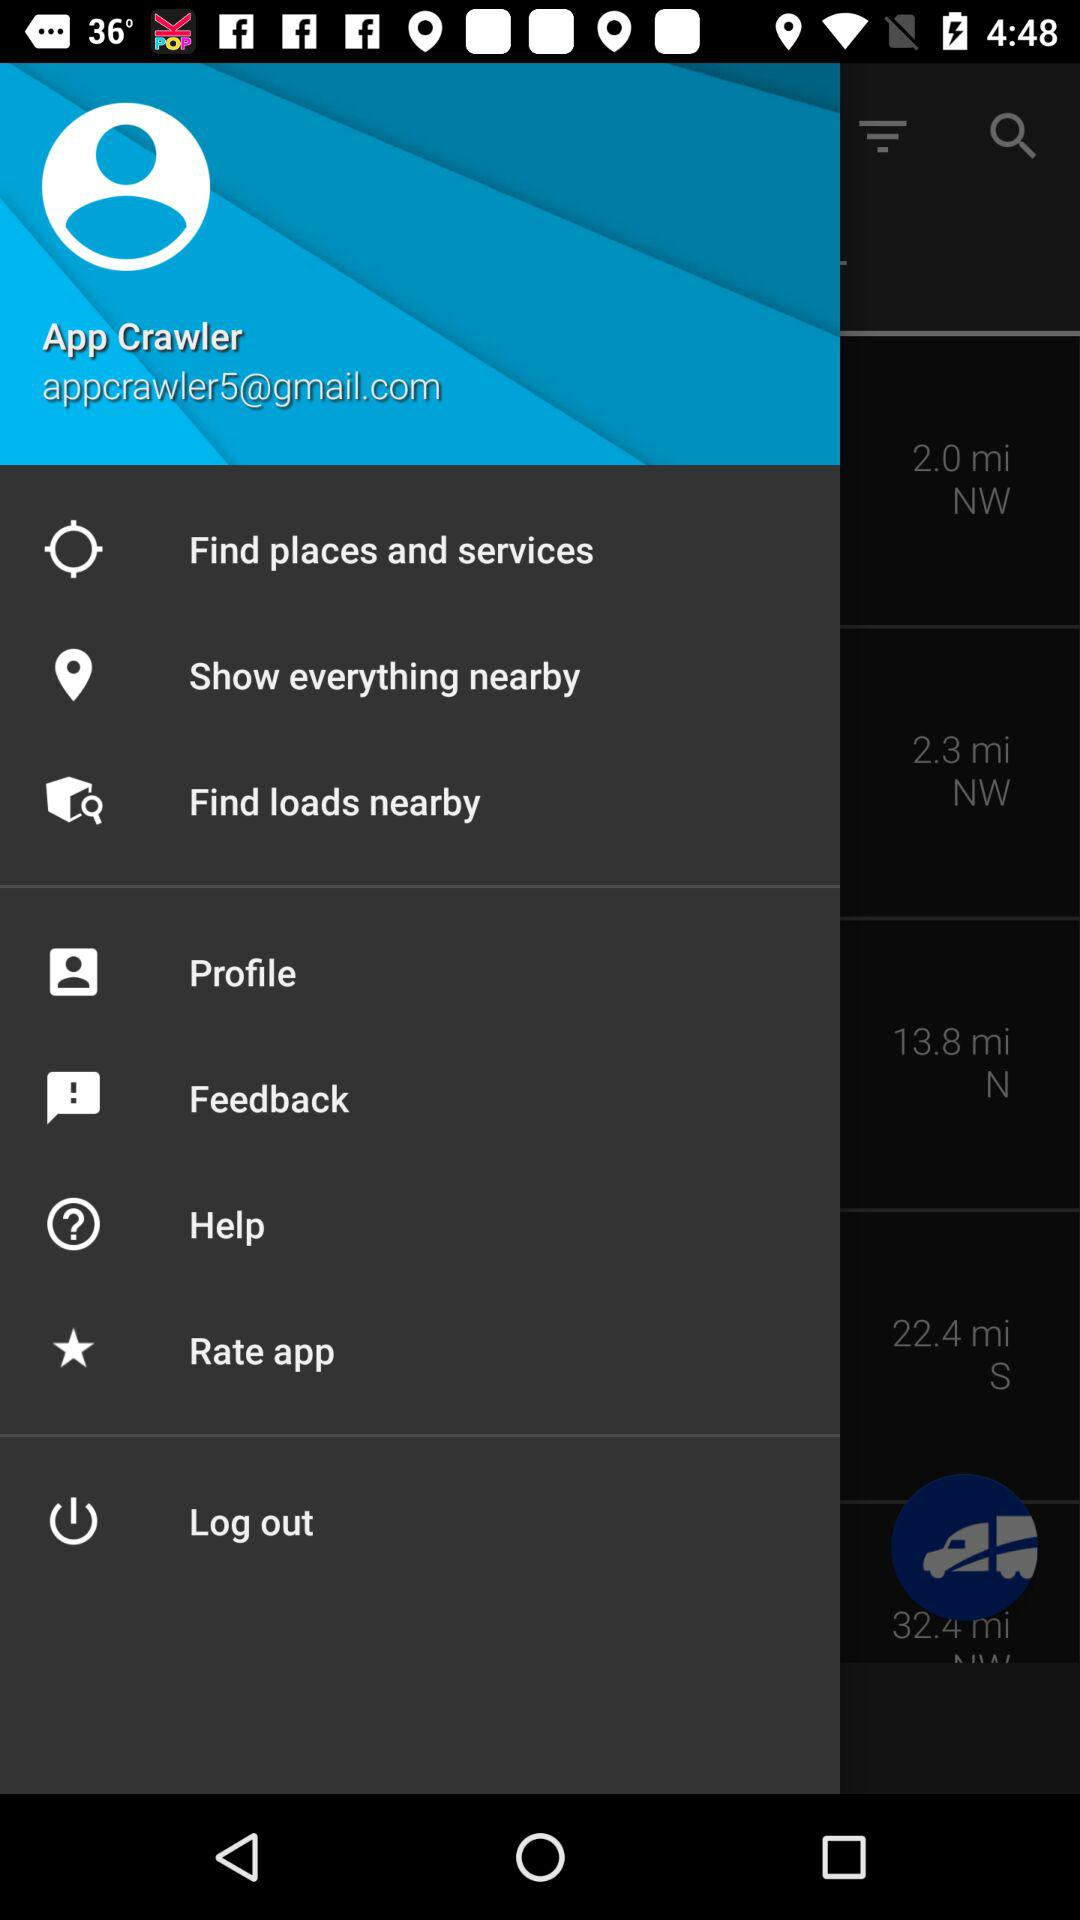What is the email ID of the user? The email ID of the user is appcrawler5@gmail.com. 